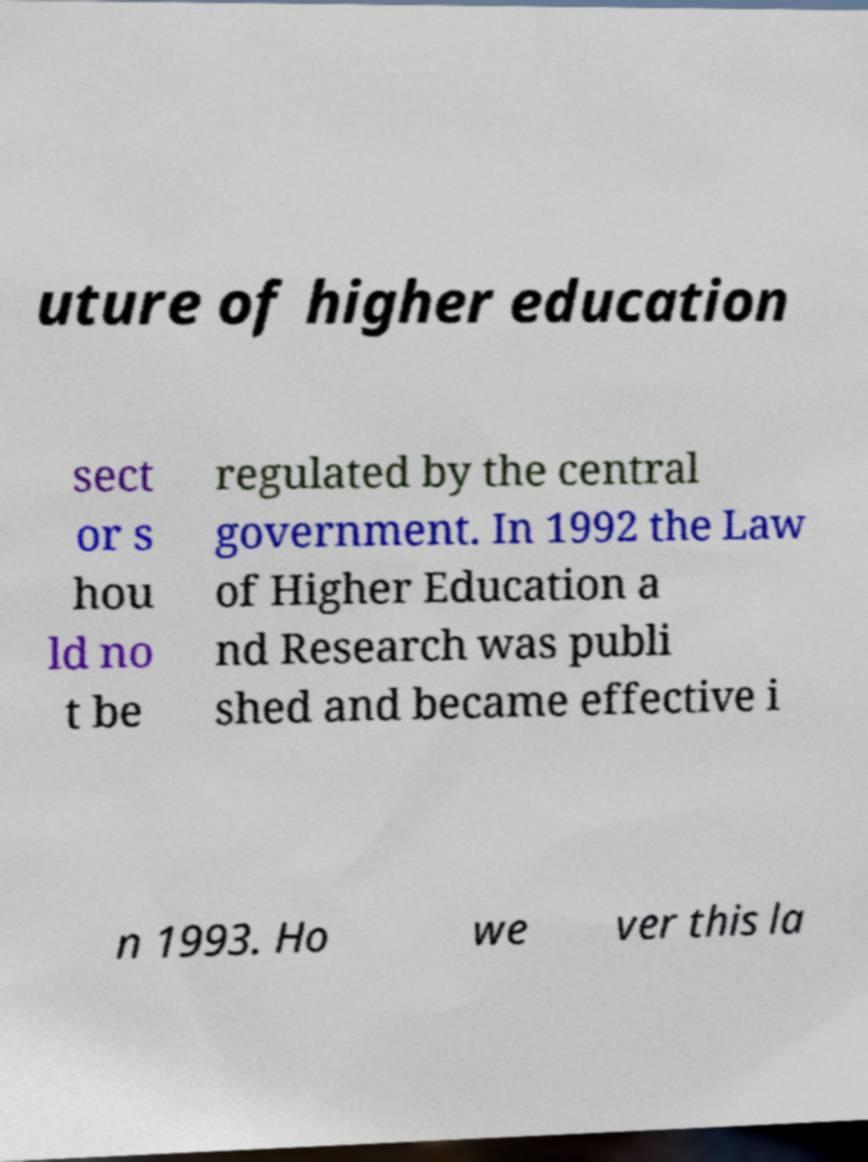Please identify and transcribe the text found in this image. uture of higher education sect or s hou ld no t be regulated by the central government. In 1992 the Law of Higher Education a nd Research was publi shed and became effective i n 1993. Ho we ver this la 